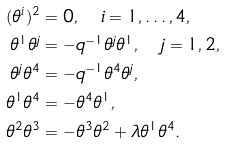Convert formula to latex. <formula><loc_0><loc_0><loc_500><loc_500>( \theta ^ { i } ) ^ { 2 } & = 0 , \quad i = 1 , \dots , 4 , \\ \theta ^ { 1 } \theta ^ { j } & = - q ^ { - 1 } \theta ^ { j } \theta ^ { 1 } , \quad j = 1 , 2 , \\ \theta ^ { j } \theta ^ { 4 } & = - q ^ { - 1 } \theta ^ { 4 } \theta ^ { j } , \\ \theta ^ { 1 } \theta ^ { 4 } & = - \theta ^ { 4 } \theta ^ { 1 } , \\ \theta ^ { 2 } \theta ^ { 3 } & = - \theta ^ { 3 } \theta ^ { 2 } + \lambda \theta ^ { 1 } \theta ^ { 4 } .</formula> 